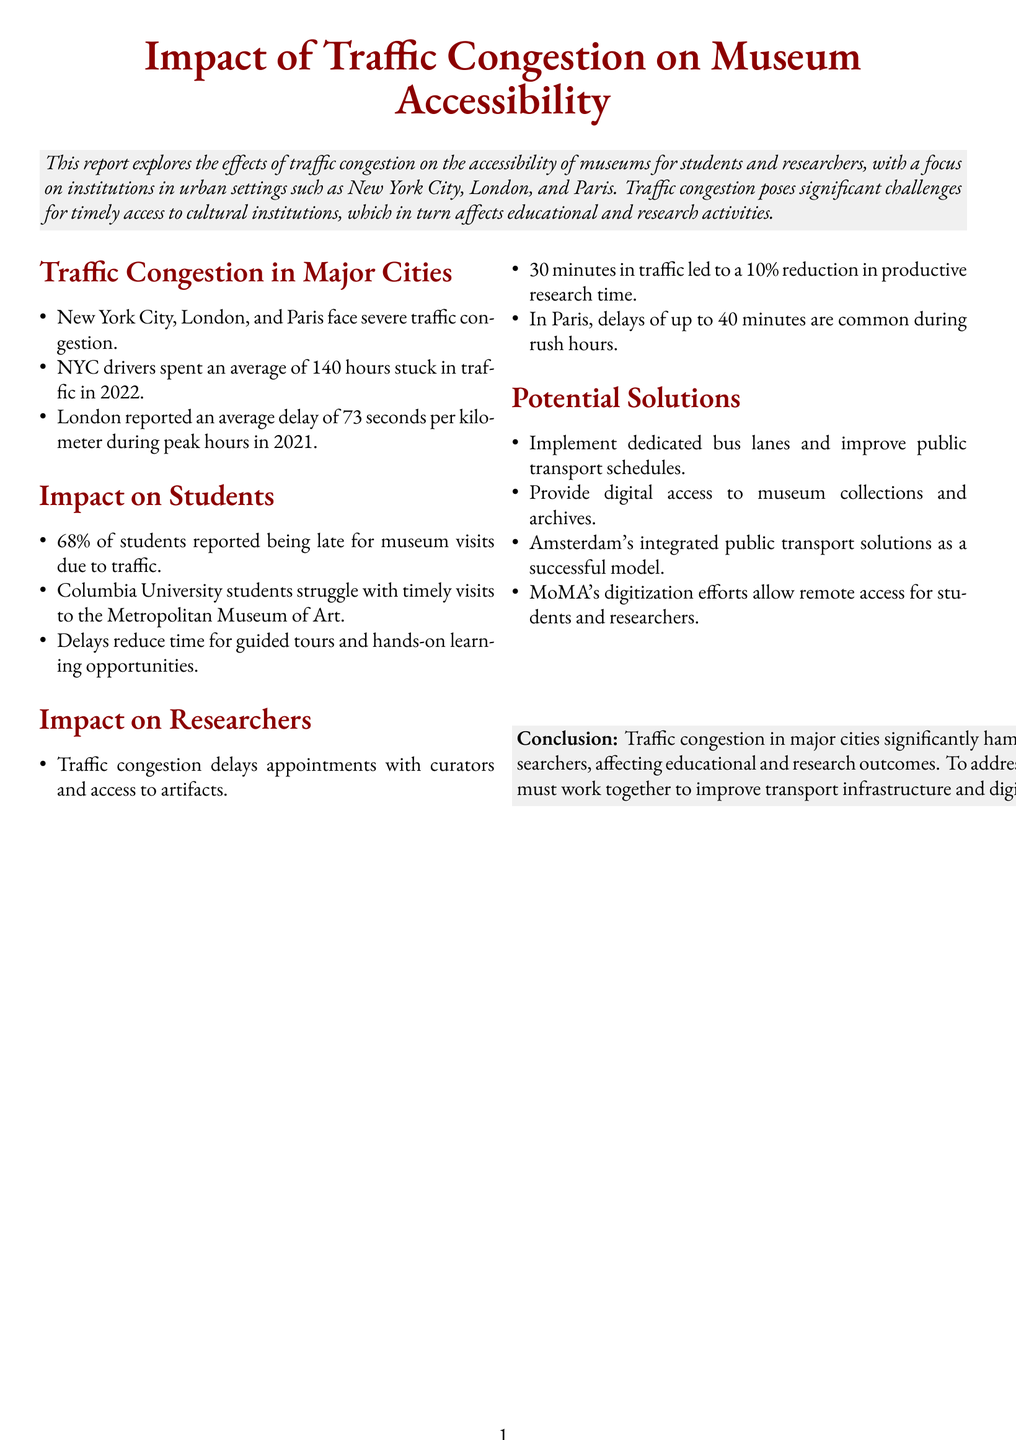What percentage of students reported being late for museum visits due to traffic? The document states that 68% of students reported being late for museum visits due to traffic.
Answer: 68% What is the average time NYC drivers spent stuck in traffic in 2022? According to the report, NYC drivers spent an average of 140 hours stuck in traffic in 2022.
Answer: 140 hours What common delay time is reported during rush hours in Paris? The report mentions that delays of up to 40 minutes are common during rush hours in Paris.
Answer: 40 minutes What impact does 30 minutes in traffic have on productive research time? The document indicates that 30 minutes in traffic led to a 10% reduction in productive research time.
Answer: 10% Which museum's digitization efforts allow remote access for students and researchers? The report highlights that MoMA's digitization efforts allow remote access for students and researchers.
Answer: MoMA What solutions are suggested to improve museum accessibility? The document lists several potential solutions, including dedicated bus lanes and digital access to collections.
Answer: Dedicated bus lanes and digital access In which urban settings does the report focus its analysis? The report emphasizes institutions in urban settings such as New York City, London, and Paris.
Answer: New York City, London, and Paris What challenge does traffic congestion pose regarding guided tours? The document states that delays reduce time for guided tours and hands-on learning opportunities.
Answer: Reduces time What percentage of students are affected by reduced time for guided tours? The impact of traffic congestion, as reflected in the students' experiences, is not quantified specifically in terms of a percentage related to tours directly but emphasizes delays.
Answer: N/A (inferred answer from the context) 